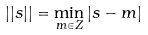Convert formula to latex. <formula><loc_0><loc_0><loc_500><loc_500>| | s | | = \min _ { m \in Z } | s - m |</formula> 